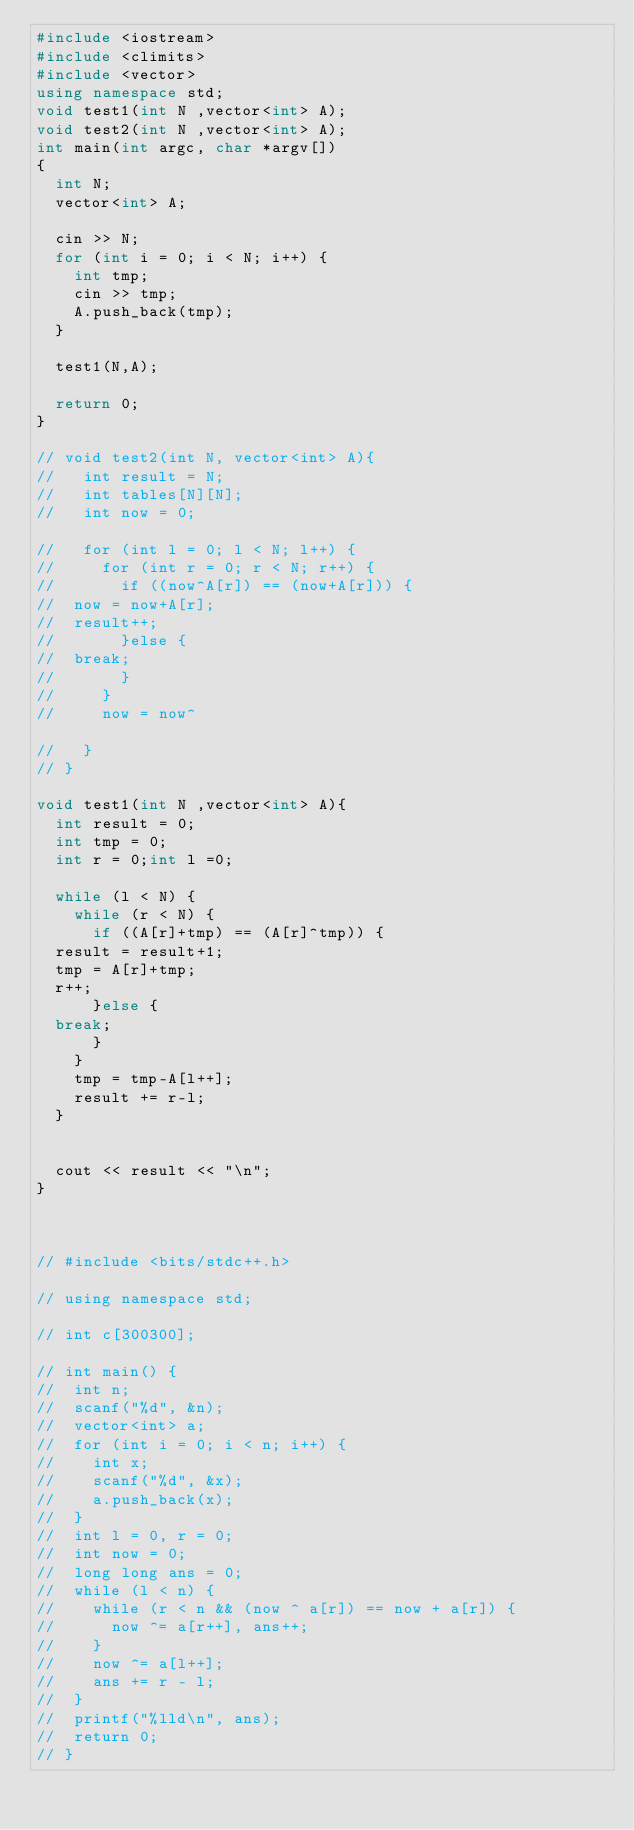Convert code to text. <code><loc_0><loc_0><loc_500><loc_500><_C++_>#include <iostream>
#include <climits>
#include <vector>
using namespace std;
void test1(int N ,vector<int> A);
void test2(int N ,vector<int> A);
int main(int argc, char *argv[])
{
  int N;
  vector<int> A;

  cin >> N;
  for (int i = 0; i < N; i++) {
    int tmp;
    cin >> tmp;
    A.push_back(tmp);
  }

  test1(N,A);

  return 0;
}

// void test2(int N, vector<int> A){
//   int result = N;
//   int tables[N][N];
//   int now = 0;

//   for (int l = 0; l < N; l++) {
//     for (int r = 0; r < N; r++) {
//       if ((now^A[r]) == (now+A[r])) {
// 	now = now+A[r];
// 	result++;
//       }else {
// 	break;
//       }
//     }
//     now = now^
    
//   }
// }

void test1(int N ,vector<int> A){
  int result = 0;
  int tmp = 0;
  int r = 0;int l =0;

  while (l < N) {
    while (r < N) {
      if ((A[r]+tmp) == (A[r]^tmp)) {
	result = result+1;
	tmp = A[r]+tmp;
	r++;
      }else {
	break;
      }
    }
    tmp = tmp-A[l++];
    result += r-l;
  }


  cout << result << "\n";  
}



// #include <bits/stdc++.h>
 
// using namespace std;
 
// int c[300300];
 
// int main() {
// 	int n;
// 	scanf("%d", &n);
// 	vector<int> a;
// 	for (int i = 0; i < n; i++) {
// 		int x;
// 		scanf("%d", &x);
// 		a.push_back(x);
// 	}
// 	int l = 0, r = 0;
// 	int now = 0;
// 	long long ans = 0;
// 	while (l < n) {
// 		while (r < n && (now ^ a[r]) == now + a[r]) {
// 			now ^= a[r++], ans++;
// 		}
// 		now ^= a[l++];
// 		ans += r - l;
// 	}
// 	printf("%lld\n", ans);
// 	return 0;
// }
</code> 